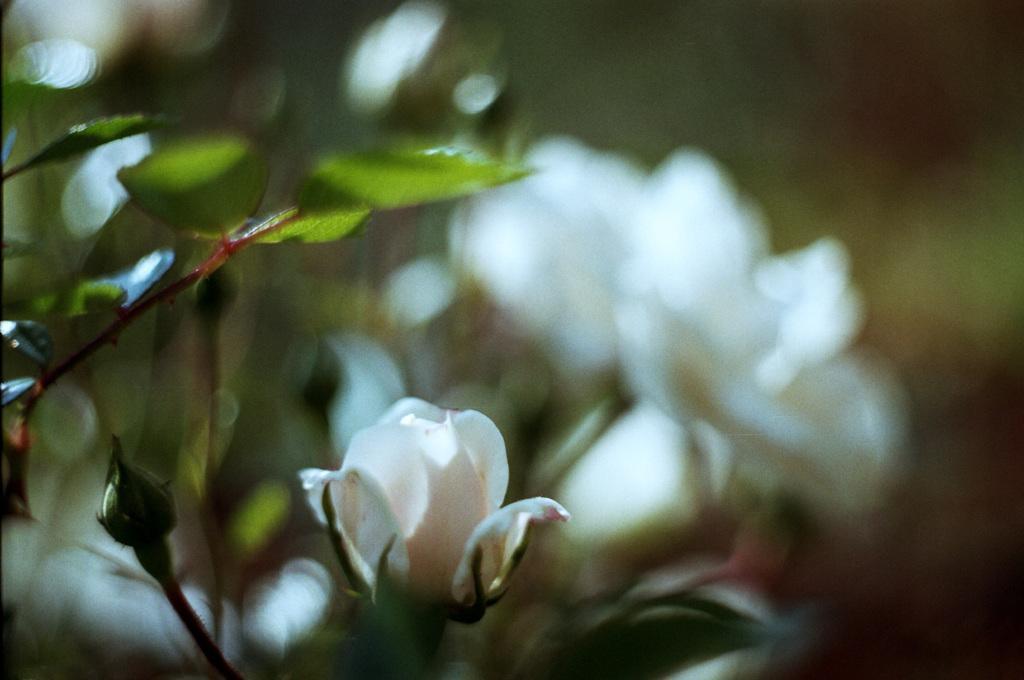Could you give a brief overview of what you see in this image? This picture shows plants with flowers. Flowers are white in color. 